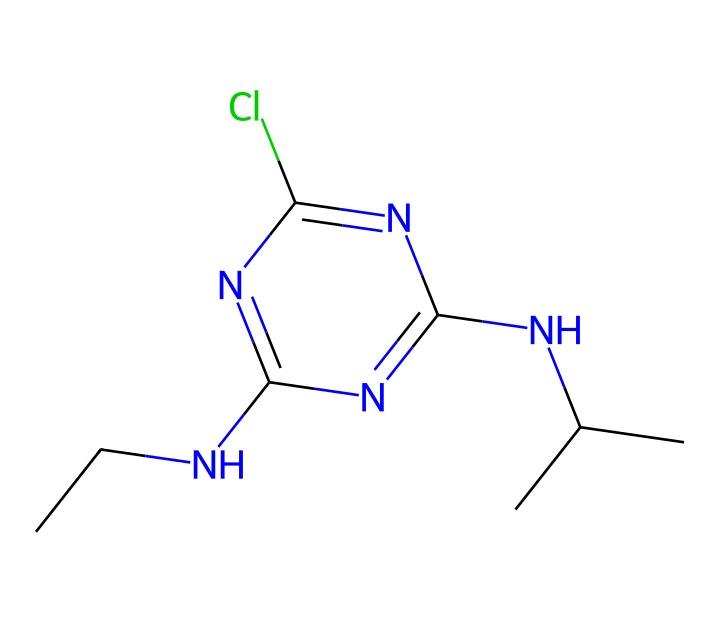What is the main functional group present in atrazine? The presence of the amino group (NH2) in the structure indicates the functional group. This is seen in the structure as an amine derivative attached to the central aromatic ring.
Answer: amino How many nitrogen atoms are present in the chemical structure of atrazine? By analyzing the SMILES representation, we can count the nitrogen (N) atoms indicated in the structure. They appear multiple times throughout the molecule, and careful counting reveals there are three nitrogen atoms.
Answer: three What is the molecular formula of atrazine based on its structure? The molecular formula can be deduced by counting all the different atoms represented in the SMILES notation. The molecule has two carbon (C) atoms, one chlorine (Cl) atom, three nitrogen (N) atoms, and additional hydrogen atoms making the complete molecular formula as C8H14ClN5.
Answer: C8H14ClN5 Which element in the structure contributes to atrazine's herbicidal properties? The chlorine atom is crucial for the herbicidal effects as it increases the compound's lipophilicity, allowing it to penetrate plant cell membranes more effectively. This structural feature contributes to its effectiveness as a herbicide.
Answer: chlorine What type of chemical reaction could atrazine undergo in the environment? Atrazine can undergo hydrolysis reactions due to the presence of the labile nitrogen bonds, potentially breaking down in aqueous solutions. This shows its instability under certain environmental conditions.
Answer: hydrolysis Is atrazine a polar or nonpolar compound based on its chemical structure? Considering the structure shows multiple nitrogen atoms and an aromatic ring, coupled with the presence of chlorine, atrazine would be considered a polar compound due to its electronegative regions that can interact with polar solvents.
Answer: polar 